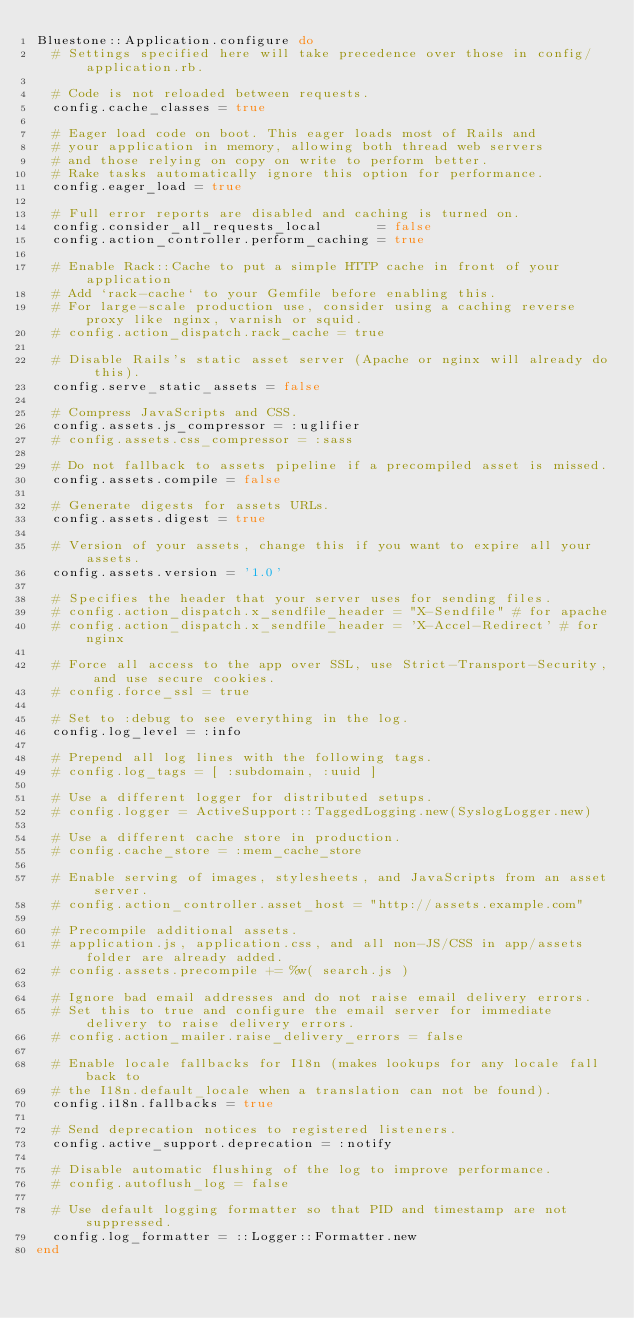Convert code to text. <code><loc_0><loc_0><loc_500><loc_500><_Ruby_>Bluestone::Application.configure do
  # Settings specified here will take precedence over those in config/application.rb.

  # Code is not reloaded between requests.
  config.cache_classes = true

  # Eager load code on boot. This eager loads most of Rails and
  # your application in memory, allowing both thread web servers
  # and those relying on copy on write to perform better.
  # Rake tasks automatically ignore this option for performance.
  config.eager_load = true

  # Full error reports are disabled and caching is turned on.
  config.consider_all_requests_local       = false
  config.action_controller.perform_caching = true

  # Enable Rack::Cache to put a simple HTTP cache in front of your application
  # Add `rack-cache` to your Gemfile before enabling this.
  # For large-scale production use, consider using a caching reverse proxy like nginx, varnish or squid.
  # config.action_dispatch.rack_cache = true

  # Disable Rails's static asset server (Apache or nginx will already do this).
  config.serve_static_assets = false

  # Compress JavaScripts and CSS.
  config.assets.js_compressor = :uglifier
  # config.assets.css_compressor = :sass

  # Do not fallback to assets pipeline if a precompiled asset is missed.
  config.assets.compile = false

  # Generate digests for assets URLs.
  config.assets.digest = true

  # Version of your assets, change this if you want to expire all your assets.
  config.assets.version = '1.0'

  # Specifies the header that your server uses for sending files.
  # config.action_dispatch.x_sendfile_header = "X-Sendfile" # for apache
  # config.action_dispatch.x_sendfile_header = 'X-Accel-Redirect' # for nginx

  # Force all access to the app over SSL, use Strict-Transport-Security, and use secure cookies.
  # config.force_ssl = true

  # Set to :debug to see everything in the log.
  config.log_level = :info

  # Prepend all log lines with the following tags.
  # config.log_tags = [ :subdomain, :uuid ]

  # Use a different logger for distributed setups.
  # config.logger = ActiveSupport::TaggedLogging.new(SyslogLogger.new)

  # Use a different cache store in production.
  # config.cache_store = :mem_cache_store

  # Enable serving of images, stylesheets, and JavaScripts from an asset server.
  # config.action_controller.asset_host = "http://assets.example.com"

  # Precompile additional assets.
  # application.js, application.css, and all non-JS/CSS in app/assets folder are already added.
  # config.assets.precompile += %w( search.js )

  # Ignore bad email addresses and do not raise email delivery errors.
  # Set this to true and configure the email server for immediate delivery to raise delivery errors.
  # config.action_mailer.raise_delivery_errors = false

  # Enable locale fallbacks for I18n (makes lookups for any locale fall back to
  # the I18n.default_locale when a translation can not be found).
  config.i18n.fallbacks = true

  # Send deprecation notices to registered listeners.
  config.active_support.deprecation = :notify

  # Disable automatic flushing of the log to improve performance.
  # config.autoflush_log = false

  # Use default logging formatter so that PID and timestamp are not suppressed.
  config.log_formatter = ::Logger::Formatter.new
end
</code> 